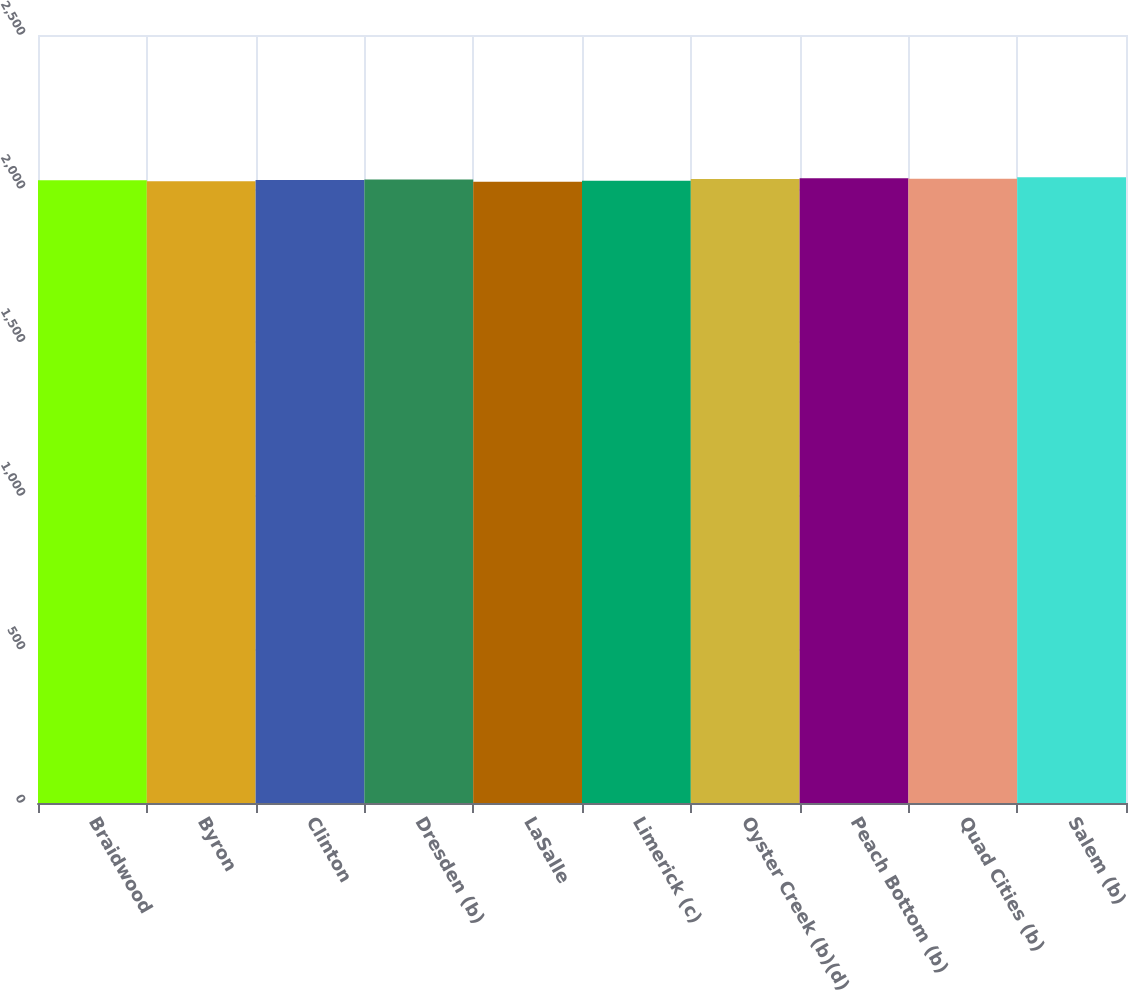Convert chart to OTSL. <chart><loc_0><loc_0><loc_500><loc_500><bar_chart><fcel>Braidwood<fcel>Byron<fcel>Clinton<fcel>Dresden (b)<fcel>LaSalle<fcel>Limerick (c)<fcel>Oyster Creek (b)(d)<fcel>Peach Bottom (b)<fcel>Quad Cities (b)<fcel>Salem (b)<nl><fcel>2026.8<fcel>2024<fcel>2028.2<fcel>2029.6<fcel>2022<fcel>2025.4<fcel>2031<fcel>2033.8<fcel>2032.4<fcel>2036.6<nl></chart> 